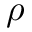<formula> <loc_0><loc_0><loc_500><loc_500>\rho</formula> 